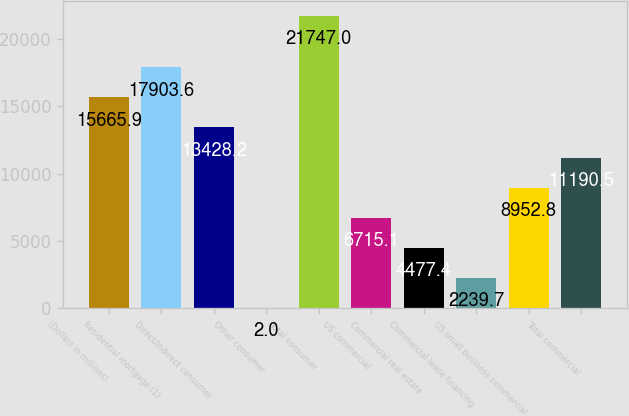<chart> <loc_0><loc_0><loc_500><loc_500><bar_chart><fcel>(Dollars in millions)<fcel>Residential mortgage (1)<fcel>Direct/Indirect consumer<fcel>Other consumer<fcel>Total consumer<fcel>US commercial<fcel>Commercial real estate<fcel>Commercial lease financing<fcel>US small business commercial<fcel>Total commercial<nl><fcel>15665.9<fcel>17903.6<fcel>13428.2<fcel>2<fcel>21747<fcel>6715.1<fcel>4477.4<fcel>2239.7<fcel>8952.8<fcel>11190.5<nl></chart> 